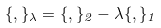<formula> <loc_0><loc_0><loc_500><loc_500>\{ , \} _ { \lambda } = \{ , \} _ { 2 } - \lambda \{ , \} _ { 1 }</formula> 